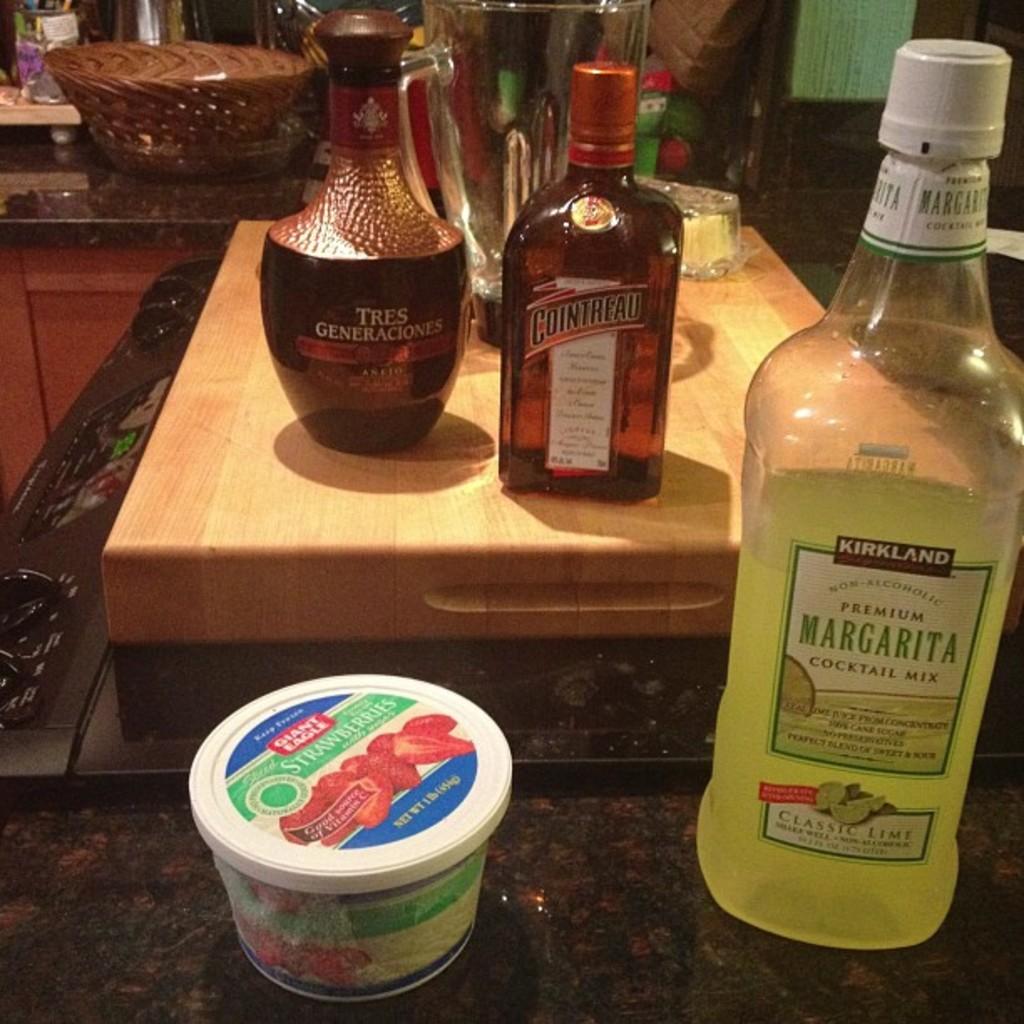What is inside of the bottles?
Provide a short and direct response. Alcohol. 